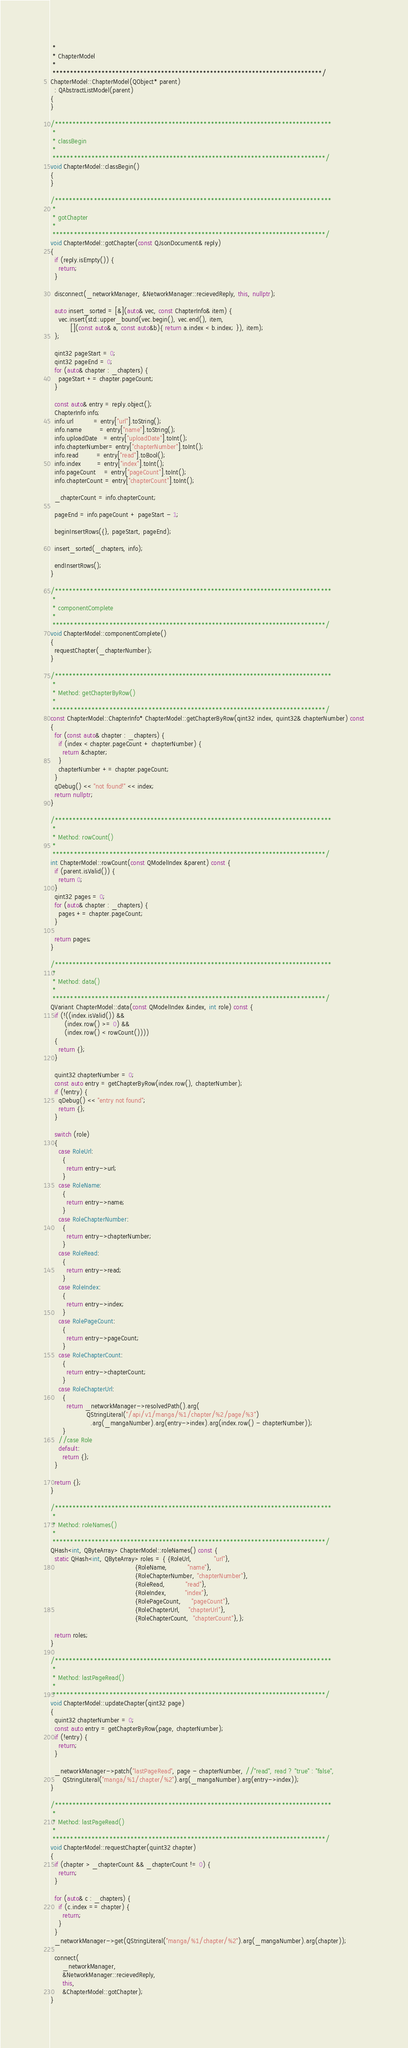Convert code to text. <code><loc_0><loc_0><loc_500><loc_500><_C++_> *
 * ChapterModel
 *
 *****************************************************************************/
ChapterModel::ChapterModel(QObject* parent)
  : QAbstractListModel(parent)
{
}

/******************************************************************************
 *
 * classBegin
 *
 *****************************************************************************/
void ChapterModel::classBegin()
{
}

/******************************************************************************
 *
 * gotChapter
 *
 *****************************************************************************/
void ChapterModel::gotChapter(const QJsonDocument& reply)
{
  if (reply.isEmpty()) {
    return;
  }

  disconnect(_networkManager, &NetworkManager::recievedReply, this, nullptr);

  auto insert_sorted = [&](auto& vec, const ChapterInfo& item) {
    vec.insert(std::upper_bound(vec.begin(), vec.end(), item,
          [](const auto& a, const auto&b){ return a.index < b.index; }), item);
  };

  qint32 pageStart = 0;
  qint32 pageEnd = 0;
  for (auto& chapter : _chapters) {
    pageStart += chapter.pageCount;
  }

  const auto& entry = reply.object();
  ChapterInfo info;
  info.url          = entry["url"].toString();
  info.name         = entry["name"].toString();
  info.uploadDate   = entry["uploadDate"].toInt();
  info.chapterNumber= entry["chapterNumber"].toInt();
  info.read         = entry["read"].toBool();
  info.index        = entry["index"].toInt();
  info.pageCount    = entry["pageCount"].toInt();
  info.chapterCount = entry["chapterCount"].toInt();

  _chapterCount = info.chapterCount;

  pageEnd = info.pageCount + pageStart - 1;

  beginInsertRows({}, pageStart, pageEnd);

  insert_sorted(_chapters, info);

  endInsertRows();
}

/******************************************************************************
 *
 * componentComplete
 *
 *****************************************************************************/
void ChapterModel::componentComplete()
{
  requestChapter(_chapterNumber);
}

/******************************************************************************
 *
 * Method: getChapterByRow()
 *
 *****************************************************************************/
const ChapterModel::ChapterInfo* ChapterModel::getChapterByRow(qint32 index, quint32& chapterNumber) const
{
  for (const auto& chapter : _chapters) {
    if (index < chapter.pageCount + chapterNumber) {
      return &chapter;
    }
    chapterNumber += chapter.pageCount;
  }
  qDebug() << "not found!" << index;
  return nullptr;
}

/******************************************************************************
 *
 * Method: rowCount()
 *
 *****************************************************************************/
int ChapterModel::rowCount(const QModelIndex &parent) const {
  if (parent.isValid()) {
    return 0;
  }
  qint32 pages = 0;
  for (auto& chapter : _chapters) {
    pages += chapter.pageCount;
  }

  return pages;
}

/******************************************************************************
 *
 * Method: data()
 *
 *****************************************************************************/
QVariant ChapterModel::data(const QModelIndex &index, int role) const {
  if (!((index.isValid()) &&
       (index.row() >= 0) &&
       (index.row() < rowCount())))
  {
    return {};
  }

  quint32 chapterNumber = 0;
  const auto entry = getChapterByRow(index.row(), chapterNumber);
  if (!entry) {
    qDebug() << "entry not found";
    return {};
  }

  switch (role)
  {
    case RoleUrl:
      {
        return entry->url;
      }
    case RoleName:
      {
        return entry->name;
      }
    case RoleChapterNumber:
      {
        return entry->chapterNumber;
      }
    case RoleRead:
      {
        return entry->read;
      }
    case RoleIndex:
      {
        return entry->index;
      }
    case RolePageCount:
      {
        return entry->pageCount;
      }
    case RoleChapterCount:
      {
        return entry->chapterCount;
      }
    case RoleChapterUrl:
      {
        return _networkManager->resolvedPath().arg(
                  QStringLiteral("/api/v1/manga/%1/chapter/%2/page/%3")
                    .arg(_mangaNumber).arg(entry->index).arg(index.row() - chapterNumber));
      }
    //case Role
    default:
      return {};
  }

  return {};
}

/******************************************************************************
 *
 * Method: roleNames()
 *
 *****************************************************************************/
QHash<int, QByteArray> ChapterModel::roleNames() const {
  static QHash<int, QByteArray> roles = { {RoleUrl,           "url"},
                                          {RoleName,          "name"},
                                          {RoleChapterNumber, "chapterNumber"},
                                          {RoleRead,          "read"},
                                          {RoleIndex,         "index"},
                                          {RolePageCount,     "pageCount"},
                                          {RoleChapterUrl,    "chapterUrl"},
                                          {RoleChapterCount,  "chapterCount"},};

  return roles;
}

/******************************************************************************
 *
 * Method: lastPageRead()
 *
 *****************************************************************************/
void ChapterModel::updateChapter(qint32 page)
{
  quint32 chapterNumber = 0;
  const auto entry = getChapterByRow(page, chapterNumber);
  if (!entry) {
    return;
  }

  _networkManager->patch("lastPageRead", page - chapterNumber, //"read", read ? "true" : "false",
      QStringLiteral("manga/%1/chapter/%2").arg(_mangaNumber).arg(entry->index));
}

/******************************************************************************
 *
 * Method: lastPageRead()
 *
 *****************************************************************************/
void ChapterModel::requestChapter(quint32 chapter)
{
  if (chapter > _chapterCount && _chapterCount != 0) {
    return;
  }

  for (auto& c : _chapters) {
    if (c.index == chapter) {
      return;
    }
  }
  _networkManager->get(QStringLiteral("manga/%1/chapter/%2").arg(_mangaNumber).arg(chapter));

  connect(
      _networkManager,
      &NetworkManager::recievedReply,
      this,
      &ChapterModel::gotChapter);
}
</code> 